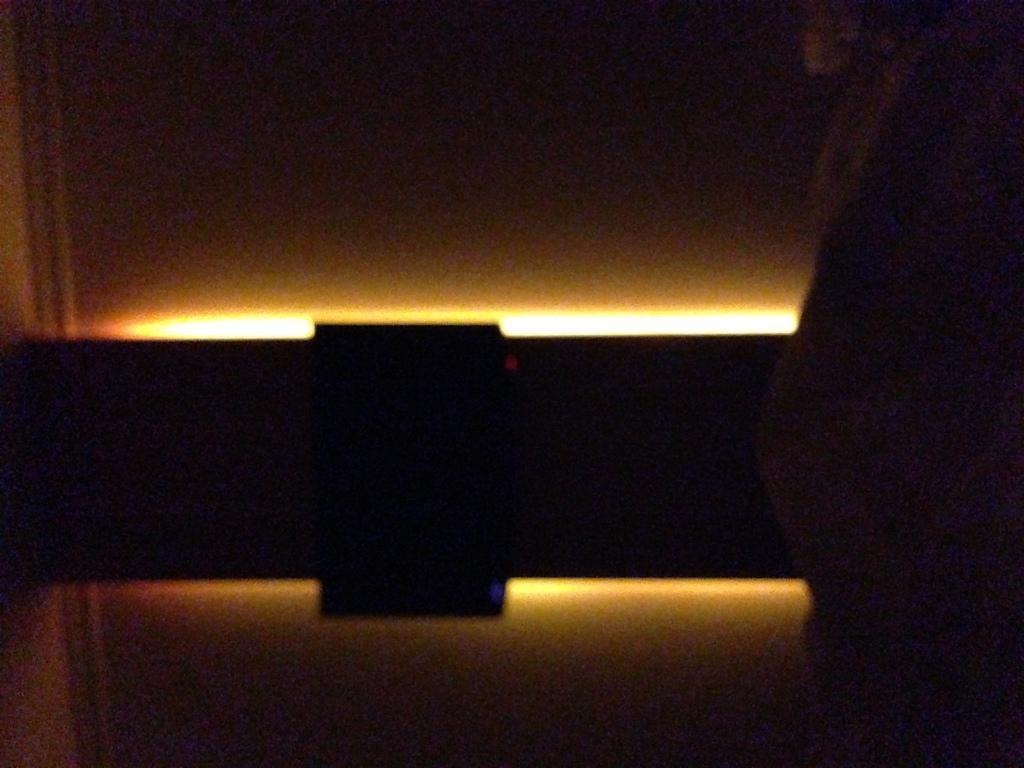Please provide a concise description of this image. This image consists of objects which are black in color. In the middle, we can see a light. In the background, it looks like a wall. 